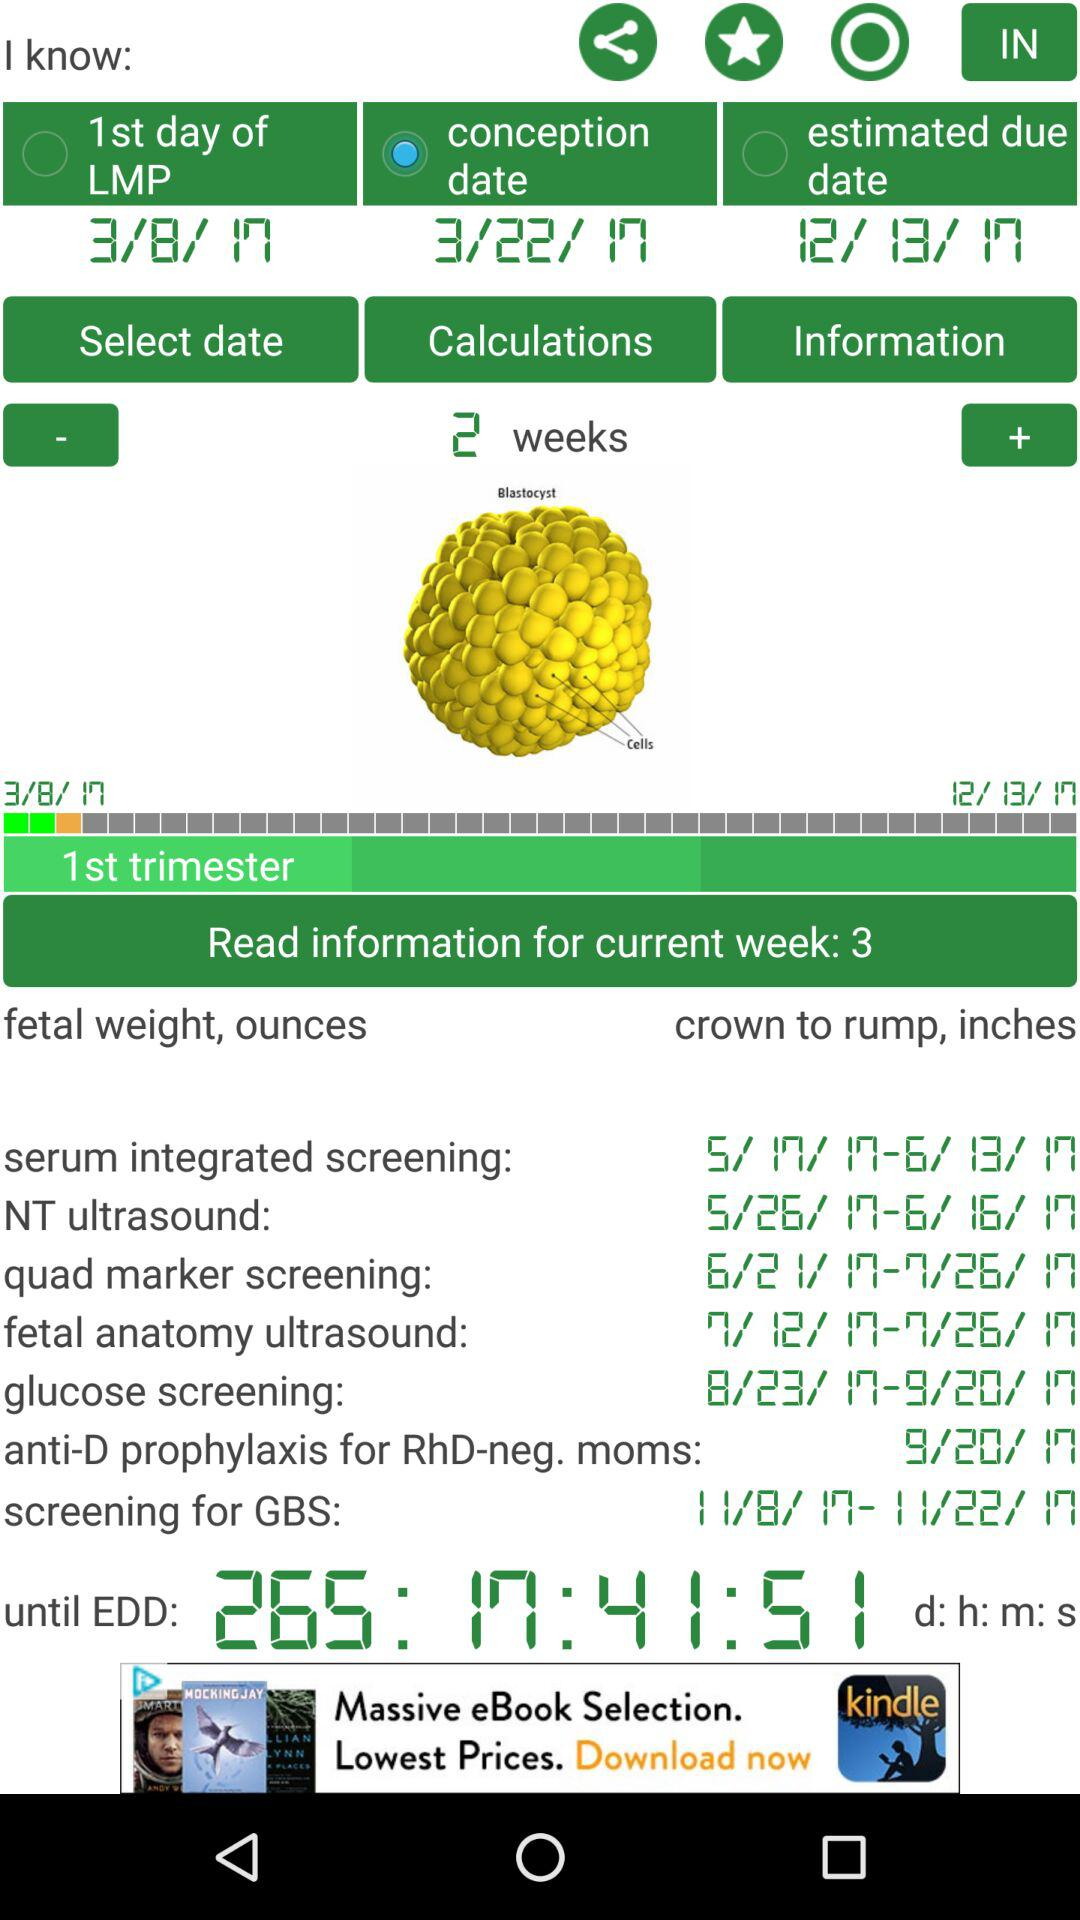What is the date for glucose screening? The dates for glucose screening are from August 23, 2017 to September 20, 2017. 